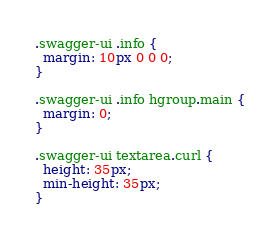Convert code to text. <code><loc_0><loc_0><loc_500><loc_500><_CSS_>.swagger-ui .info {
  margin: 10px 0 0 0;
}

.swagger-ui .info hgroup.main {
  margin: 0;
}

.swagger-ui textarea.curl {
  height: 35px;
  min-height: 35px;
}
</code> 